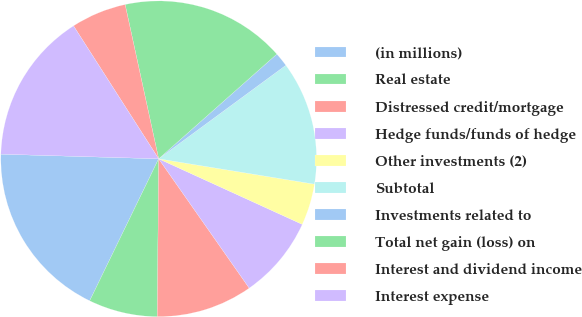Convert chart. <chart><loc_0><loc_0><loc_500><loc_500><pie_chart><fcel>(in millions)<fcel>Real estate<fcel>Distressed credit/mortgage<fcel>Hedge funds/funds of hedge<fcel>Other investments (2)<fcel>Subtotal<fcel>Investments related to<fcel>Total net gain (loss) on<fcel>Interest and dividend income<fcel>Interest expense<nl><fcel>18.27%<fcel>7.06%<fcel>9.86%<fcel>8.46%<fcel>4.25%<fcel>12.66%<fcel>1.45%<fcel>16.87%<fcel>5.66%<fcel>15.47%<nl></chart> 